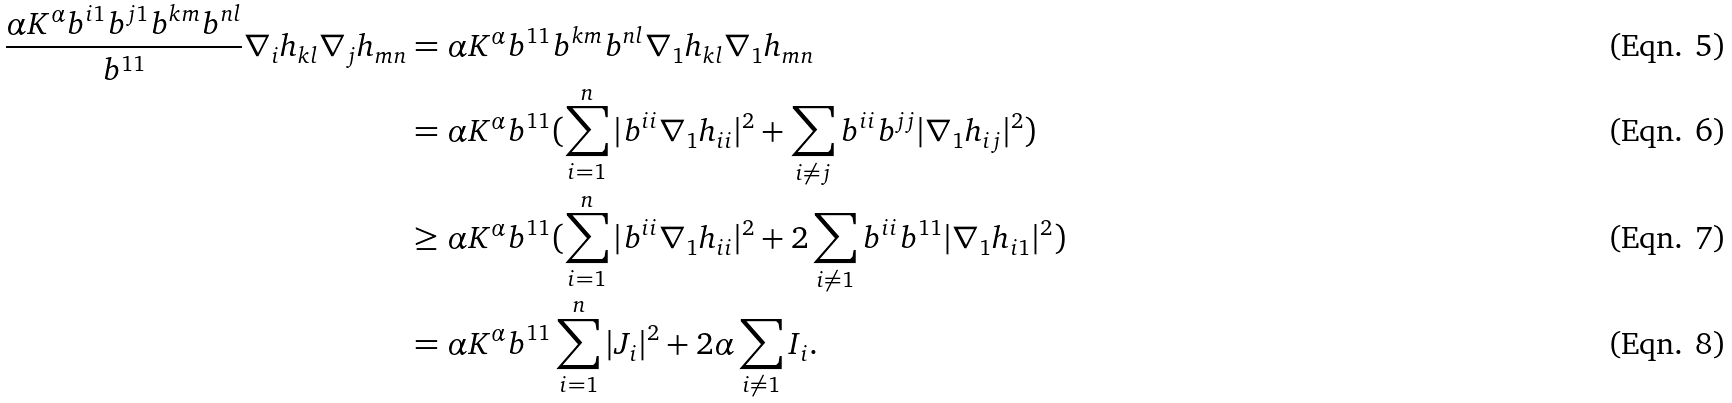Convert formula to latex. <formula><loc_0><loc_0><loc_500><loc_500>\frac { \alpha K ^ { \alpha } b ^ { i 1 } b ^ { j 1 } b ^ { k m } b ^ { n l } } { b ^ { 1 1 } } \nabla _ { i } h _ { k l } \nabla _ { j } h _ { m n } & = \alpha K ^ { \alpha } b ^ { 1 1 } b ^ { k m } b ^ { n l } \nabla _ { 1 } h _ { k l } \nabla _ { 1 } h _ { m n } \\ & = \alpha K ^ { \alpha } b ^ { 1 1 } ( \sum ^ { n } _ { i = 1 } | b ^ { i i } \nabla _ { 1 } h _ { i i } | ^ { 2 } + \sum _ { i \neq j } b ^ { i i } b ^ { j j } | \nabla _ { 1 } h _ { i j } | ^ { 2 } ) \\ & \geq \alpha K ^ { \alpha } b ^ { 1 1 } ( \sum ^ { n } _ { i = 1 } | b ^ { i i } \nabla _ { 1 } h _ { i i } | ^ { 2 } + 2 \sum _ { i \neq 1 } b ^ { i i } b ^ { 1 1 } | \nabla _ { 1 } h _ { i 1 } | ^ { 2 } ) \\ & = \alpha K ^ { \alpha } b ^ { 1 1 } \sum ^ { n } _ { i = 1 } | J _ { i } | ^ { 2 } + 2 \alpha \sum _ { i \neq 1 } I _ { i } .</formula> 